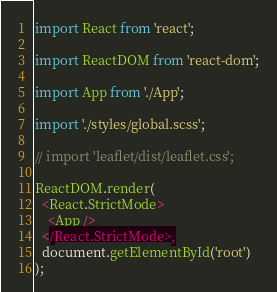<code> <loc_0><loc_0><loc_500><loc_500><_TypeScript_>import React from 'react';

import ReactDOM from 'react-dom';

import App from './App';

import './styles/global.scss';

// import 'leaflet/dist/leaflet.css';

ReactDOM.render(
  <React.StrictMode>
    <App />
  </React.StrictMode>,
  document.getElementById('root')
);</code> 